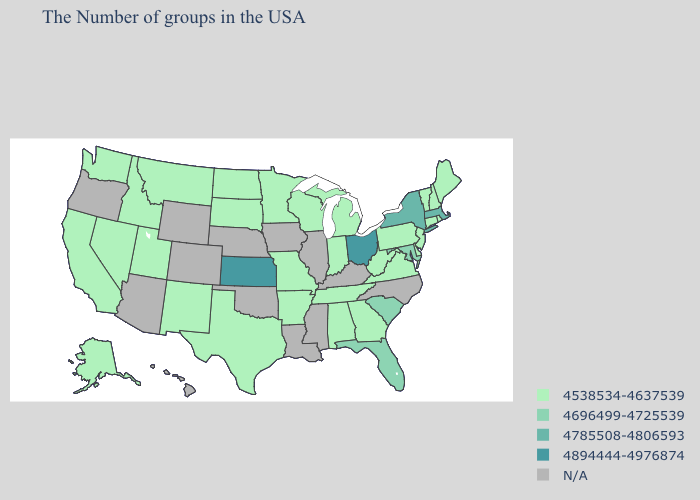What is the value of Illinois?
Concise answer only. N/A. What is the lowest value in states that border New Hampshire?
Be succinct. 4538534-4637539. What is the lowest value in the West?
Short answer required. 4538534-4637539. Name the states that have a value in the range N/A?
Give a very brief answer. North Carolina, Kentucky, Illinois, Mississippi, Louisiana, Iowa, Nebraska, Oklahoma, Wyoming, Colorado, Arizona, Oregon, Hawaii. Does Kansas have the lowest value in the USA?
Be succinct. No. What is the lowest value in the Northeast?
Quick response, please. 4538534-4637539. Among the states that border Maryland , which have the lowest value?
Answer briefly. Delaware, Pennsylvania, Virginia, West Virginia. What is the value of Delaware?
Be succinct. 4538534-4637539. What is the highest value in states that border Idaho?
Short answer required. 4538534-4637539. Among the states that border Massachusetts , does Rhode Island have the lowest value?
Write a very short answer. Yes. What is the value of Washington?
Answer briefly. 4538534-4637539. Name the states that have a value in the range 4538534-4637539?
Write a very short answer. Maine, Rhode Island, New Hampshire, Vermont, Connecticut, New Jersey, Delaware, Pennsylvania, Virginia, West Virginia, Georgia, Michigan, Indiana, Alabama, Tennessee, Wisconsin, Missouri, Arkansas, Minnesota, Texas, South Dakota, North Dakota, New Mexico, Utah, Montana, Idaho, Nevada, California, Washington, Alaska. What is the value of Florida?
Be succinct. 4696499-4725539. 